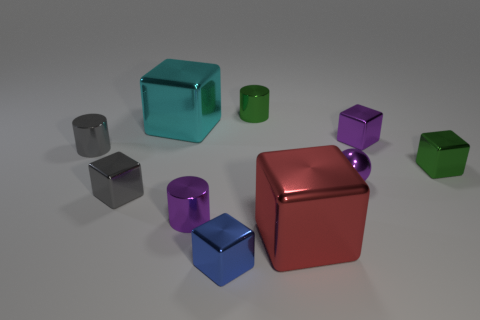Subtract 4 blocks. How many blocks are left? 2 Subtract all blue blocks. How many blocks are left? 5 Subtract all gray shiny cubes. How many cubes are left? 5 Subtract all red cubes. Subtract all cyan spheres. How many cubes are left? 5 Subtract all balls. How many objects are left? 9 Add 7 small blue things. How many small blue things exist? 8 Subtract 0 brown balls. How many objects are left? 10 Subtract all cyan metal blocks. Subtract all large metal things. How many objects are left? 7 Add 5 red objects. How many red objects are left? 6 